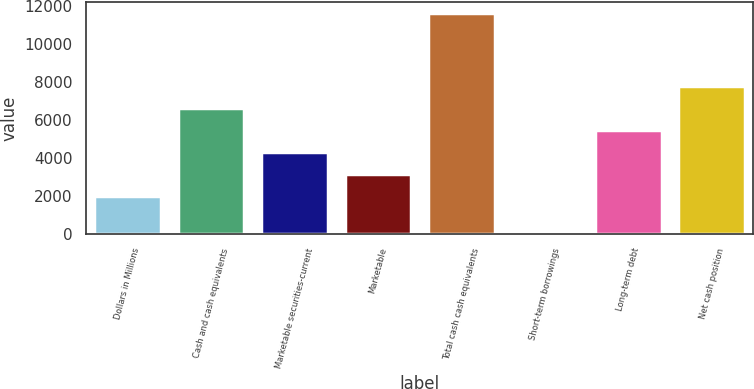Convert chart to OTSL. <chart><loc_0><loc_0><loc_500><loc_500><bar_chart><fcel>Dollars in Millions<fcel>Cash and cash equivalents<fcel>Marketable securities-current<fcel>Marketable<fcel>Total cash cash equivalents<fcel>Short-term borrowings<fcel>Long-term debt<fcel>Net cash position<nl><fcel>2011<fcel>6621.8<fcel>4316.4<fcel>3163.7<fcel>11642<fcel>115<fcel>5469.1<fcel>7774.5<nl></chart> 